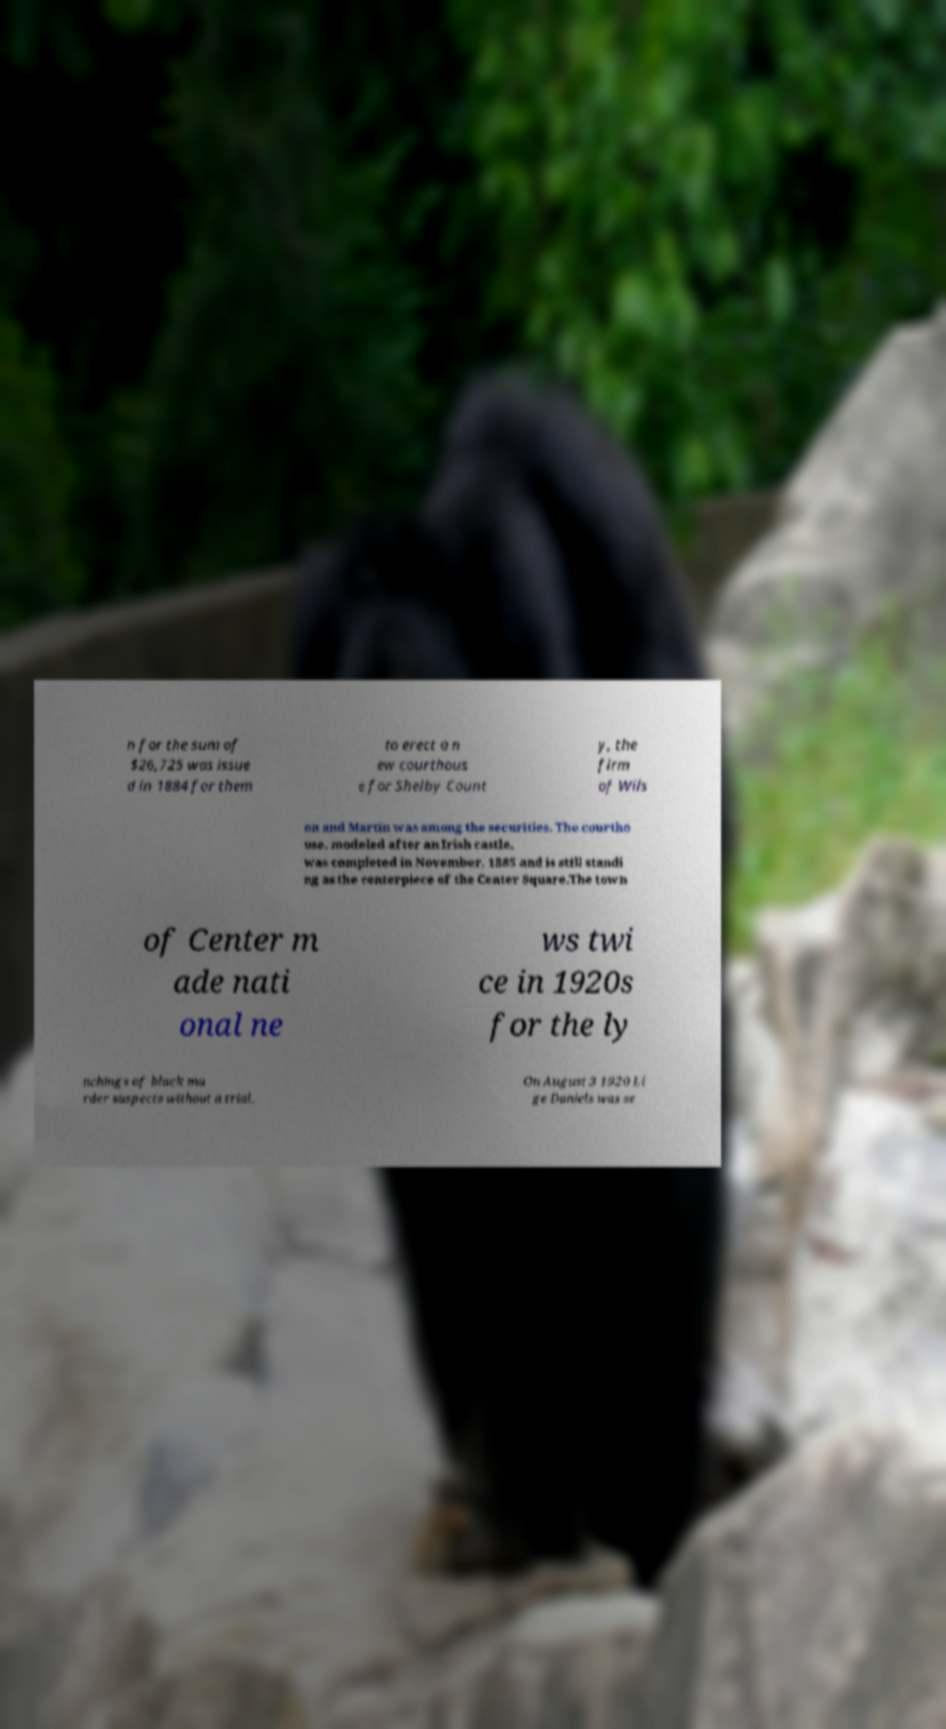Please identify and transcribe the text found in this image. n for the sum of $26,725 was issue d in 1884 for them to erect a n ew courthous e for Shelby Count y, the firm of Wils on and Martin was among the securities. The courtho use, modeled after an Irish castle, was completed in November, 1885 and is still standi ng as the centerpiece of the Center Square.The town of Center m ade nati onal ne ws twi ce in 1920s for the ly nchings of black mu rder suspects without a trial. On August 3 1920 Li ge Daniels was se 